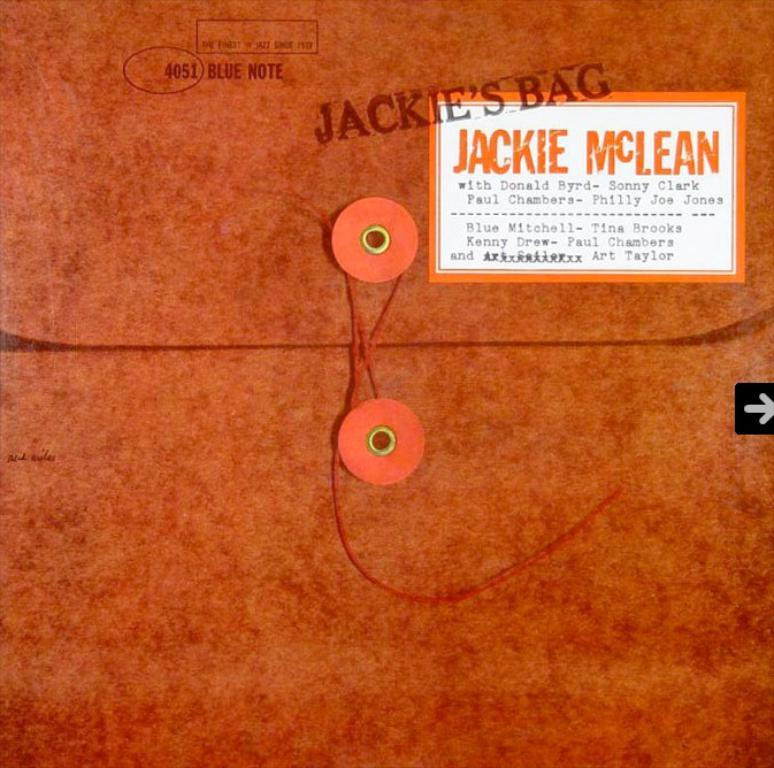<image>
Give a short and clear explanation of the subsequent image. image of Jackie's bag with a tag on it 